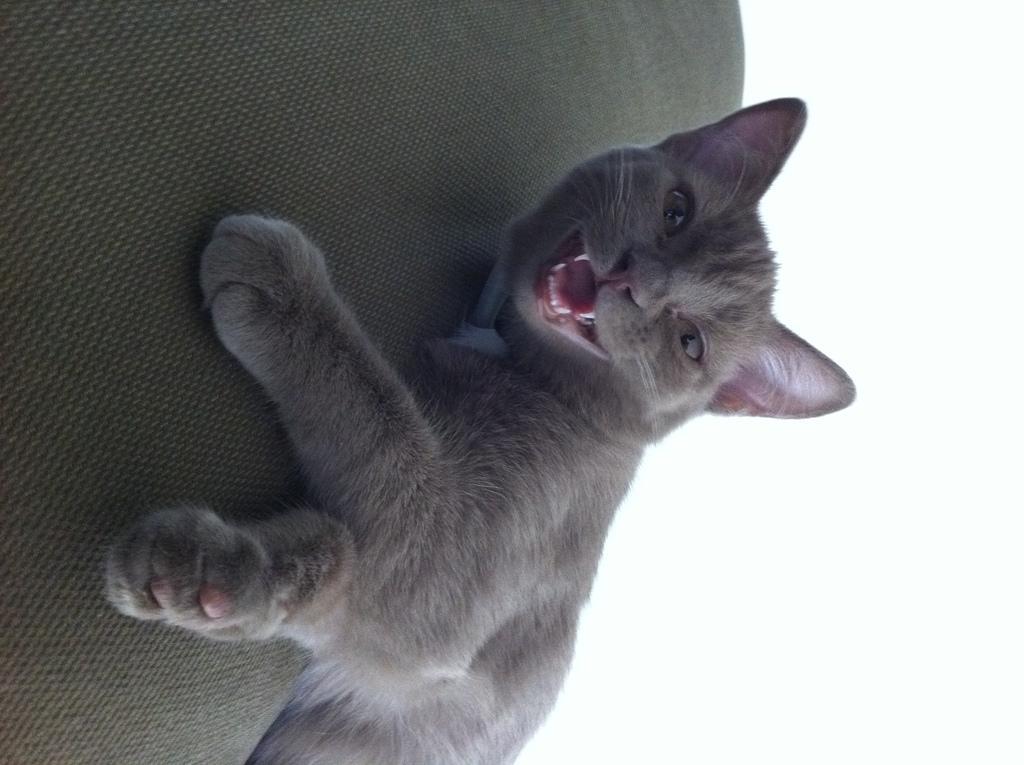Describe this image in one or two sentences. In this image we can see a cat on the couch, and the right side of the image is white in color. 